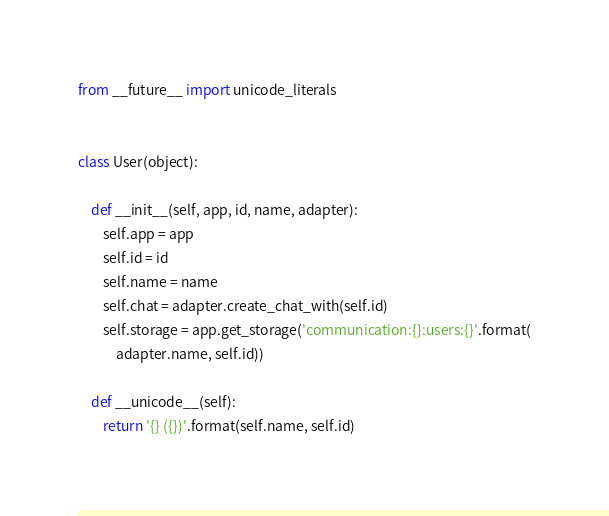Convert code to text. <code><loc_0><loc_0><loc_500><loc_500><_Python_>from __future__ import unicode_literals


class User(object):

    def __init__(self, app, id, name, adapter):
        self.app = app
        self.id = id
        self.name = name
        self.chat = adapter.create_chat_with(self.id)
        self.storage = app.get_storage('communication:{}:users:{}'.format(
            adapter.name, self.id))

    def __unicode__(self):
        return '{} ({})'.format(self.name, self.id)
</code> 